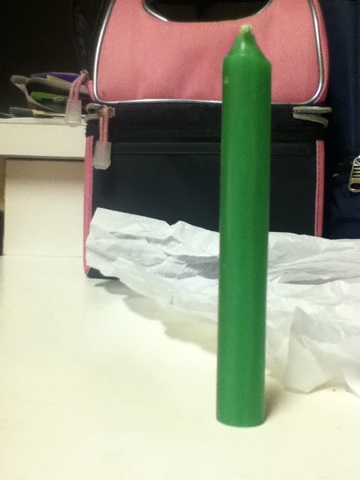What is the texture of the candle's surface? The candle's surface appears smooth and free of any major textures, which might suggest it has a soft, regular wax finish, ideal for even burning. 